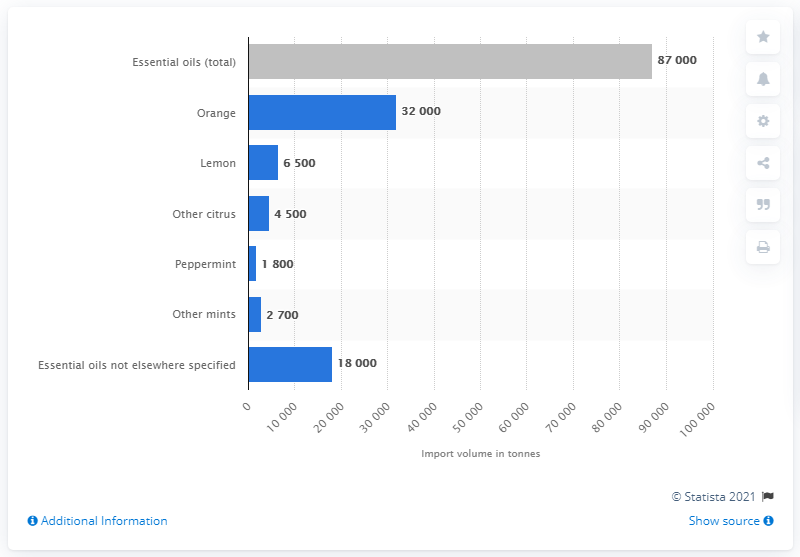Mention a couple of crucial points in this snapshot. The most popular fragrance was orange. 